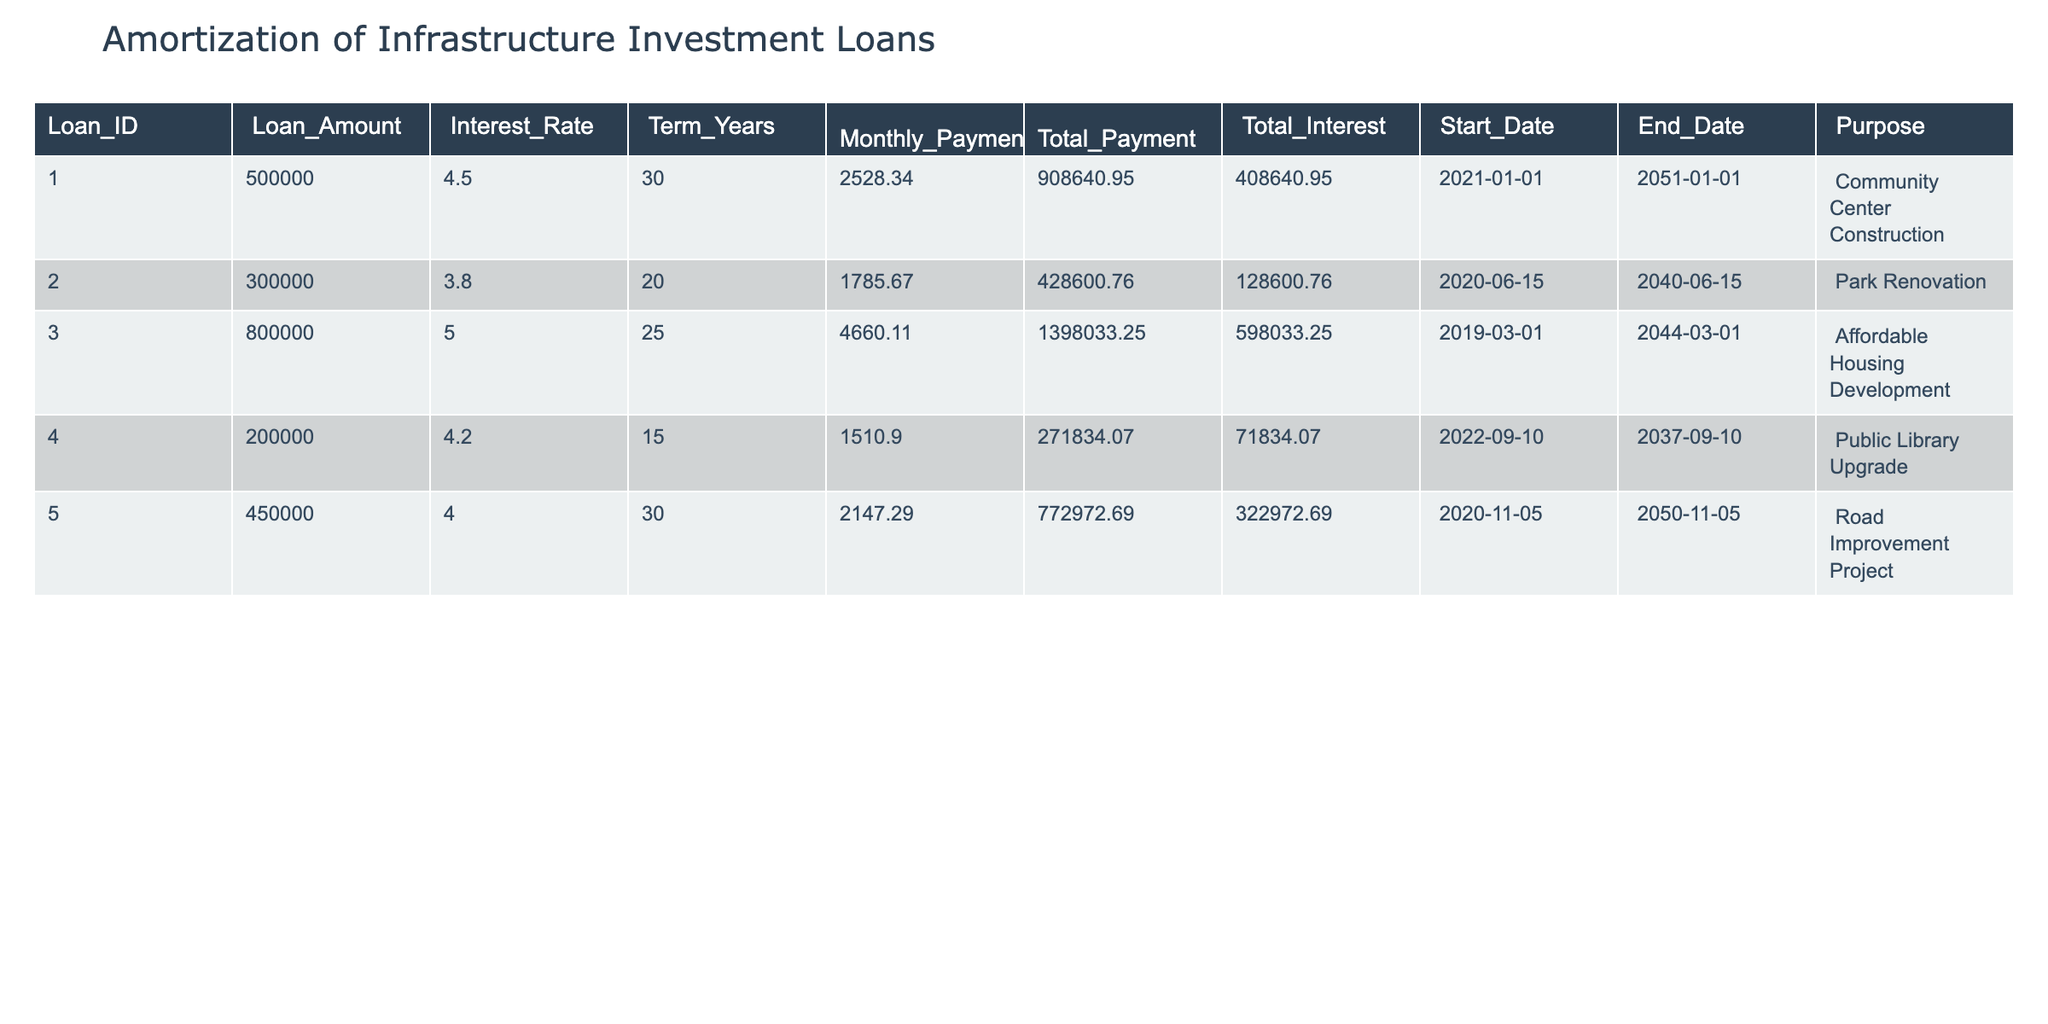What is the loan amount for the Affordable Housing Development? To find the loan amount for the Affordable Housing Development, we locate the row corresponding to that purpose. The loan amount listed in that row is $800,000.
Answer: $800,000 What is the total payment for the Community Center Construction loan? Looking at the row for the Community Center Construction, the total payment listed is $908,640.95.
Answer: $908,640.95 Which loan has the highest total interest paid? We compare the total interest for each loan: Community Center Construction ($408,640.95), Park Renovation ($128,600.76), Affordable Housing Development ($598,033.25), Public Library Upgrade ($71,834.07), and Road Improvement Project ($322,972.69). The highest is Affordable Housing Development with $598,033.25.
Answer: Affordable Housing Development What is the average loan amount of all loans listed? To calculate the average loan amount, we sum the loan amounts: $500,000 + $300,000 + $800,000 + $200,000 + $450,000 = $2,250,000. Then, we divide this sum by the number of loans, which is 5, resulting in an average loan amount of $2,250,000 / 5 = $450,000.
Answer: $450,000 Does the Park Renovation loan have an interest rate greater than 4%? The interest rate for the Park Renovation loan is 3.8%, which is less than 4%. Therefore, the statement is false.
Answer: No 